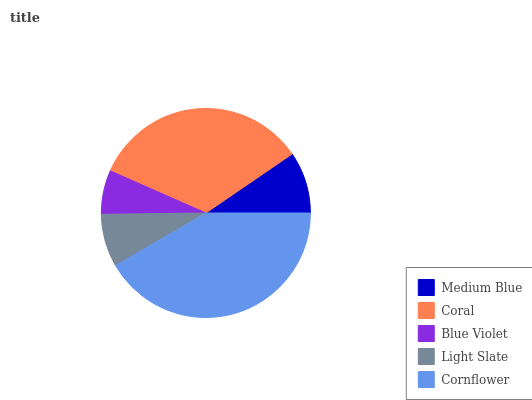Is Blue Violet the minimum?
Answer yes or no. Yes. Is Cornflower the maximum?
Answer yes or no. Yes. Is Coral the minimum?
Answer yes or no. No. Is Coral the maximum?
Answer yes or no. No. Is Coral greater than Medium Blue?
Answer yes or no. Yes. Is Medium Blue less than Coral?
Answer yes or no. Yes. Is Medium Blue greater than Coral?
Answer yes or no. No. Is Coral less than Medium Blue?
Answer yes or no. No. Is Medium Blue the high median?
Answer yes or no. Yes. Is Medium Blue the low median?
Answer yes or no. Yes. Is Blue Violet the high median?
Answer yes or no. No. Is Coral the low median?
Answer yes or no. No. 